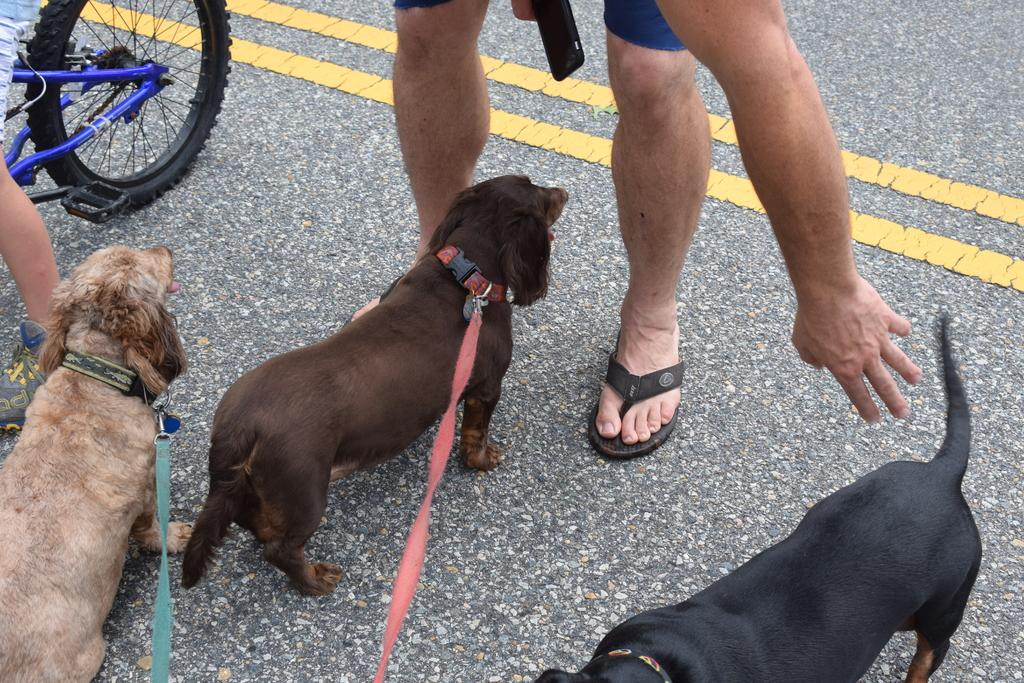How many dogs are in the image? There are three dogs in the image. Can you describe the colors of the dogs? One dog is cream-colored, one is brown-colored, and one is black-colored. What else can be seen in the background of the image? There is a person standing and a bicycle on the road in the background of the image. Can you tell me how many snails are crawling on the pen in the image? There are no snails or pens present in the image. What type of spark can be seen coming from the dogs in the image? There is no spark visible in the image; it features three dogs and a background scene. 